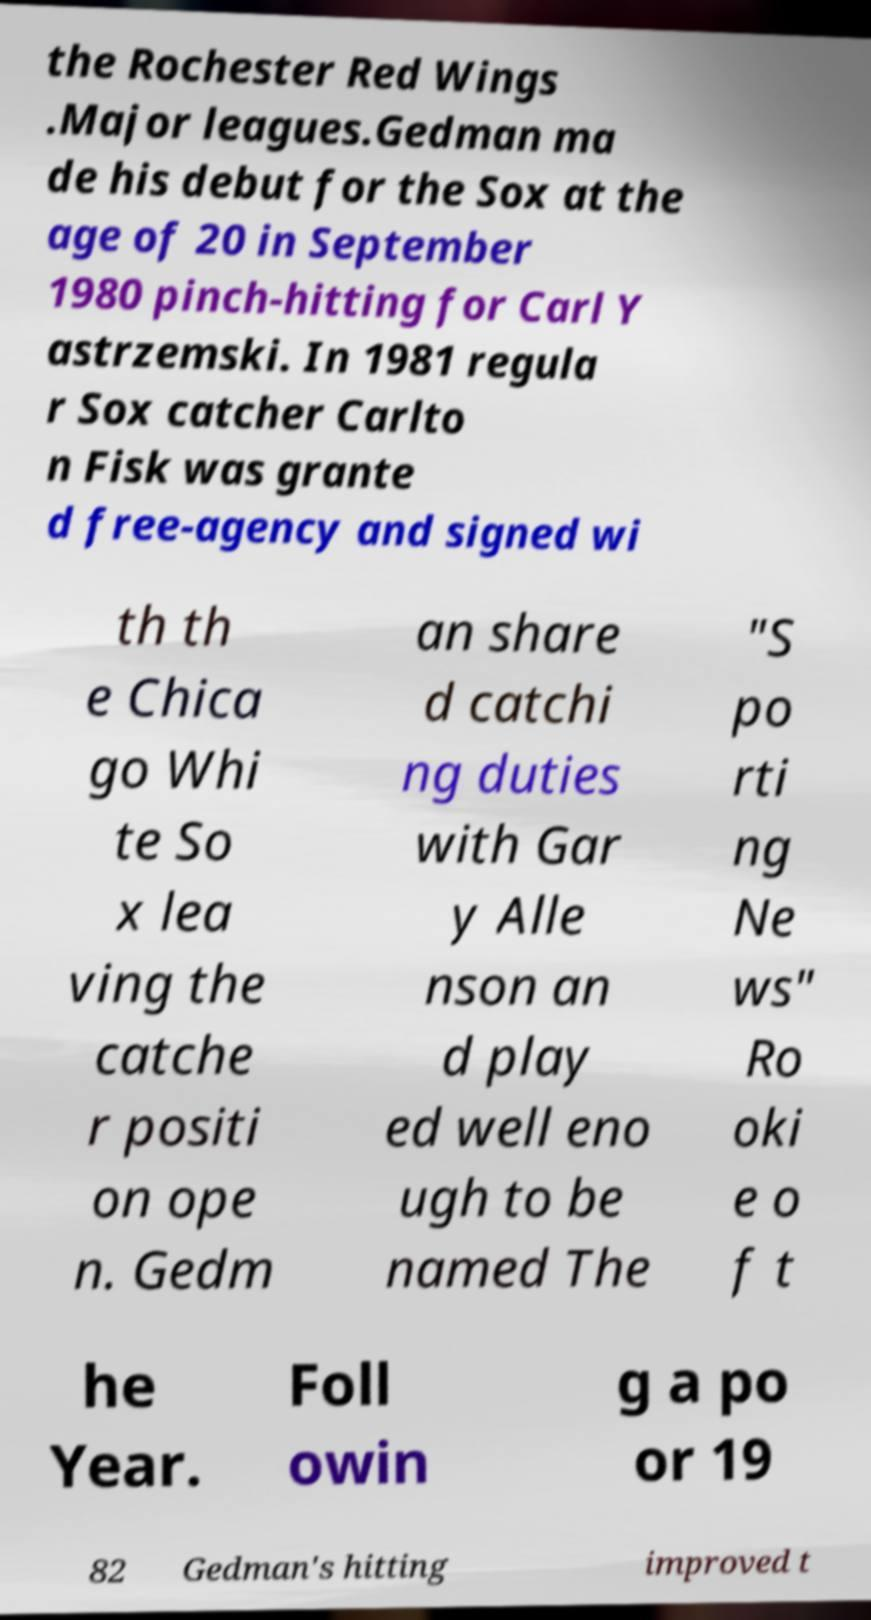Could you extract and type out the text from this image? the Rochester Red Wings .Major leagues.Gedman ma de his debut for the Sox at the age of 20 in September 1980 pinch-hitting for Carl Y astrzemski. In 1981 regula r Sox catcher Carlto n Fisk was grante d free-agency and signed wi th th e Chica go Whi te So x lea ving the catche r positi on ope n. Gedm an share d catchi ng duties with Gar y Alle nson an d play ed well eno ugh to be named The "S po rti ng Ne ws" Ro oki e o f t he Year. Foll owin g a po or 19 82 Gedman's hitting improved t 